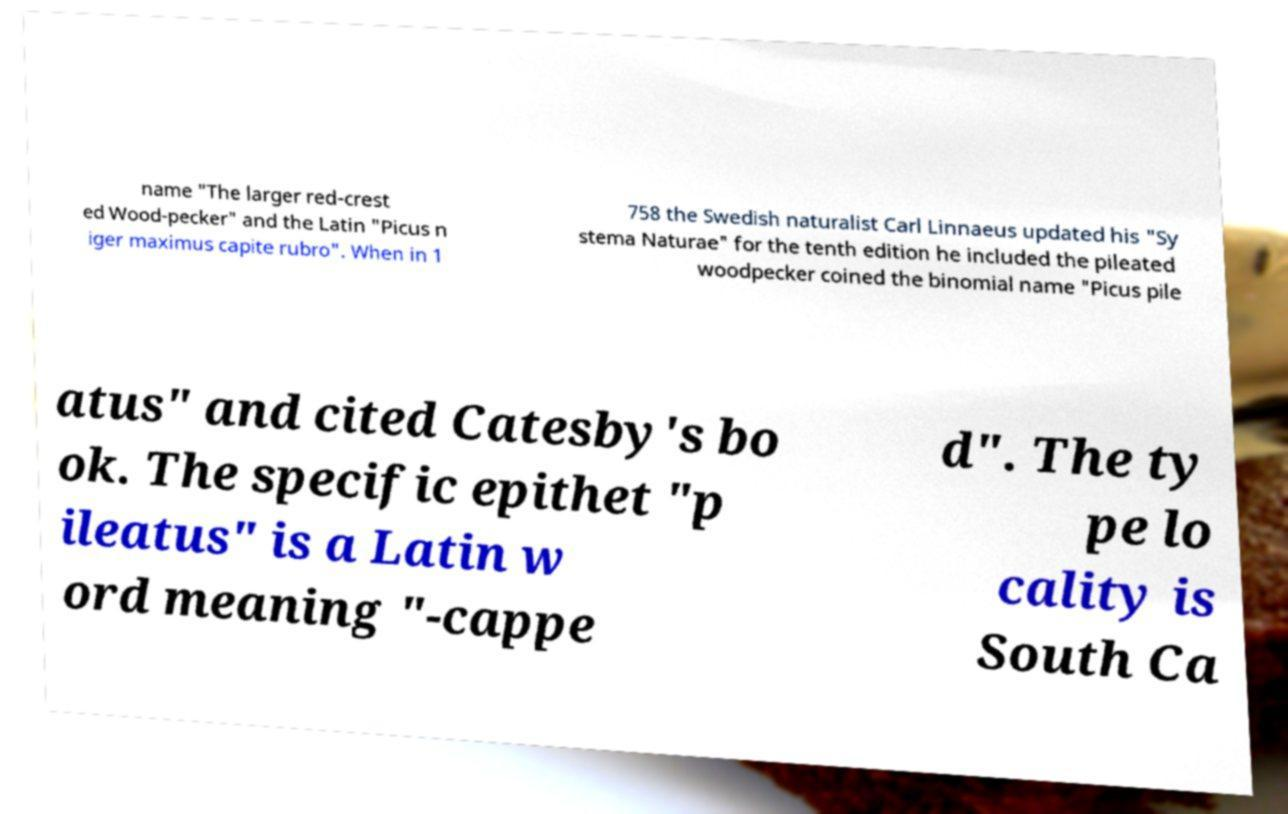I need the written content from this picture converted into text. Can you do that? name "The larger red-crest ed Wood-pecker" and the Latin "Picus n iger maximus capite rubro". When in 1 758 the Swedish naturalist Carl Linnaeus updated his "Sy stema Naturae" for the tenth edition he included the pileated woodpecker coined the binomial name "Picus pile atus" and cited Catesby's bo ok. The specific epithet "p ileatus" is a Latin w ord meaning "-cappe d". The ty pe lo cality is South Ca 